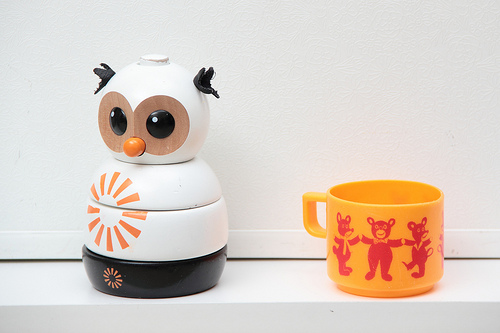<image>
Can you confirm if the bear is on the mug? Yes. Looking at the image, I can see the bear is positioned on top of the mug, with the mug providing support. 